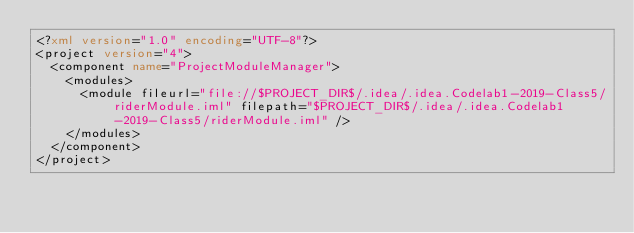Convert code to text. <code><loc_0><loc_0><loc_500><loc_500><_XML_><?xml version="1.0" encoding="UTF-8"?>
<project version="4">
  <component name="ProjectModuleManager">
    <modules>
      <module fileurl="file://$PROJECT_DIR$/.idea/.idea.Codelab1-2019-Class5/riderModule.iml" filepath="$PROJECT_DIR$/.idea/.idea.Codelab1-2019-Class5/riderModule.iml" />
    </modules>
  </component>
</project></code> 